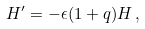Convert formula to latex. <formula><loc_0><loc_0><loc_500><loc_500>H ^ { \prime } = - \epsilon ( 1 + q ) H \, ,</formula> 